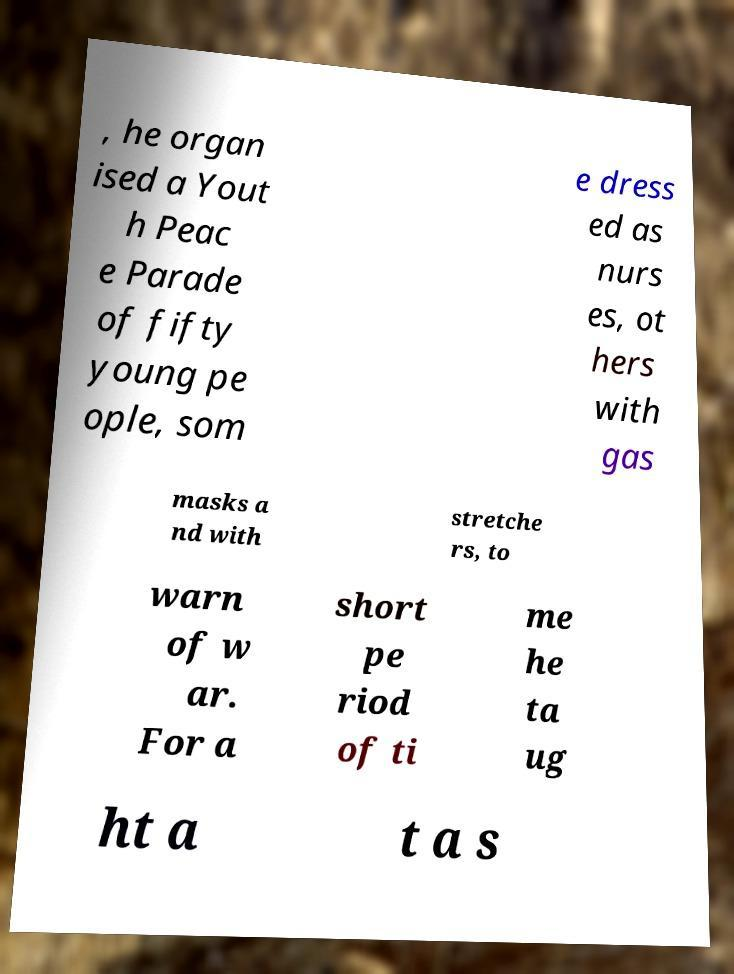There's text embedded in this image that I need extracted. Can you transcribe it verbatim? , he organ ised a Yout h Peac e Parade of fifty young pe ople, som e dress ed as nurs es, ot hers with gas masks a nd with stretche rs, to warn of w ar. For a short pe riod of ti me he ta ug ht a t a s 